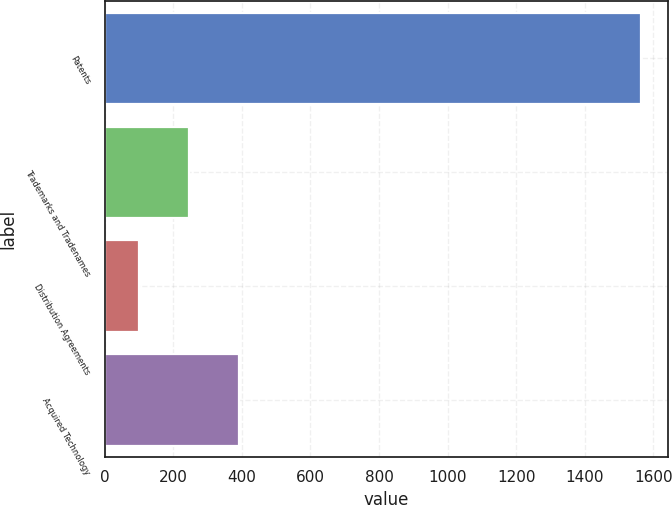Convert chart. <chart><loc_0><loc_0><loc_500><loc_500><bar_chart><fcel>Patents<fcel>Trademarks and Tradenames<fcel>Distribution Agreements<fcel>Acquired Technology<nl><fcel>1564<fcel>245.5<fcel>99<fcel>392<nl></chart> 